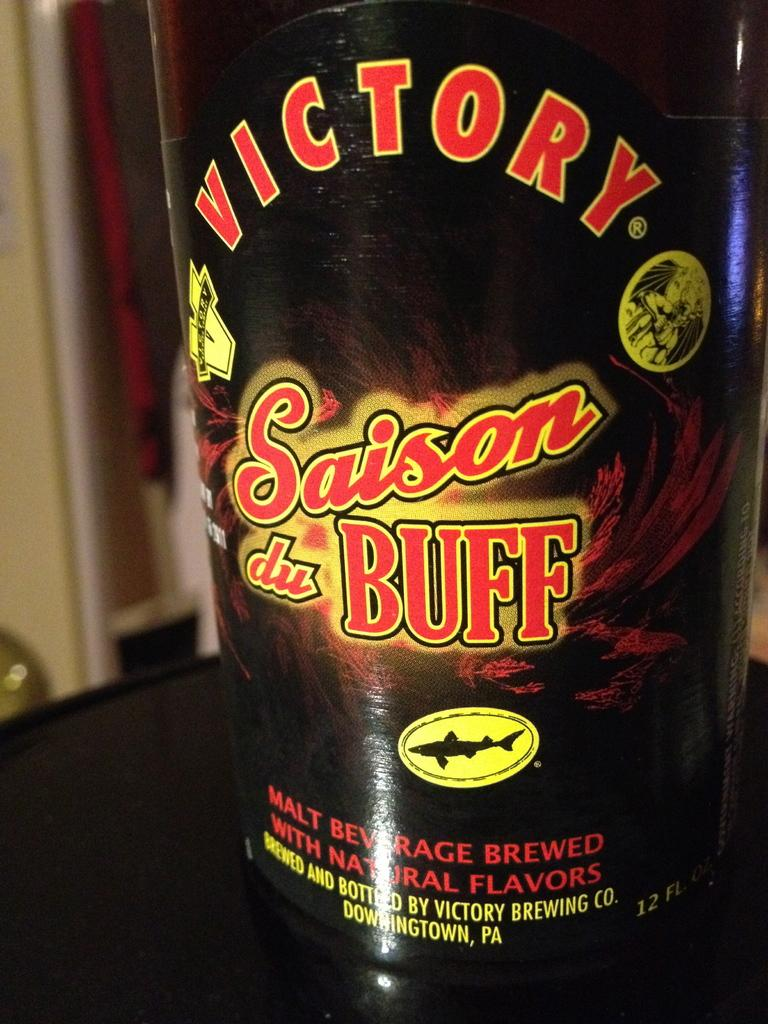Provide a one-sentence caption for the provided image. A bottle of malt beverage by Victory labeled Saison du buff. 